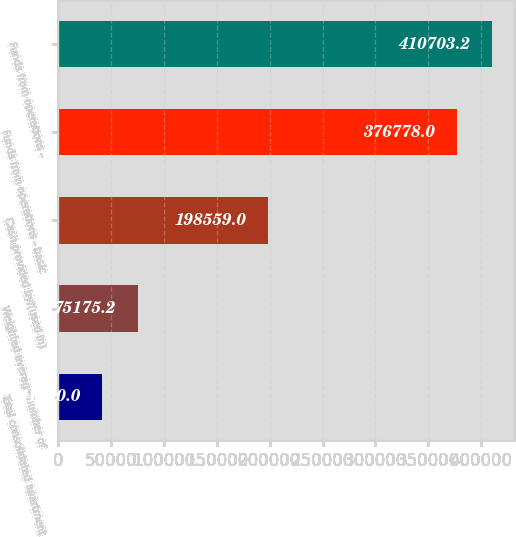<chart> <loc_0><loc_0><loc_500><loc_500><bar_chart><fcel>Total consolidated apartment<fcel>Weighted average number of<fcel>Cash provided by/(used in)<fcel>Funds from operations - basic<fcel>Funds from operations -<nl><fcel>41250<fcel>75175.2<fcel>198559<fcel>376778<fcel>410703<nl></chart> 